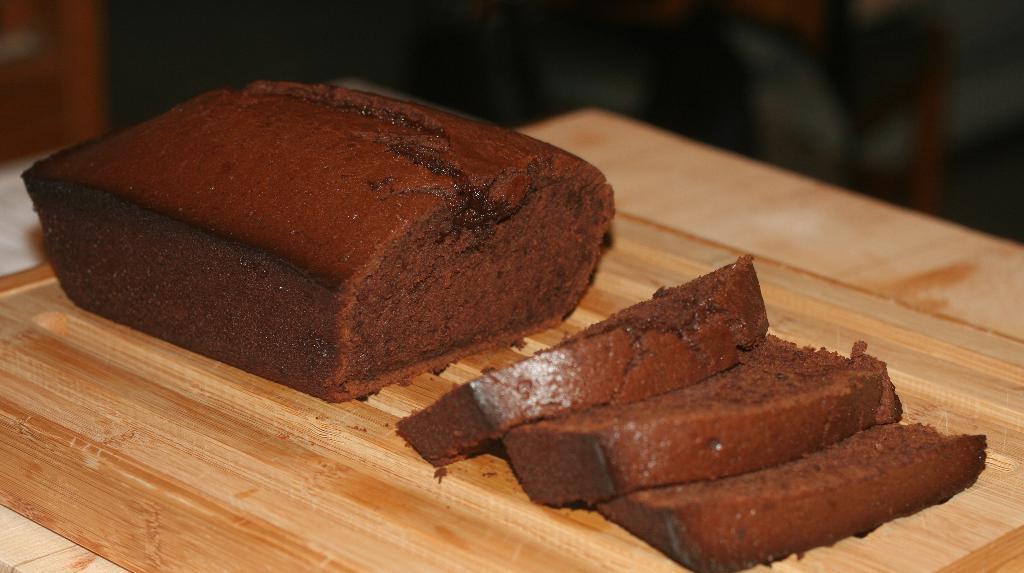Could you give a brief overview of what you see in this image? In this picture we can see few cake pieces on the wooden plank. 